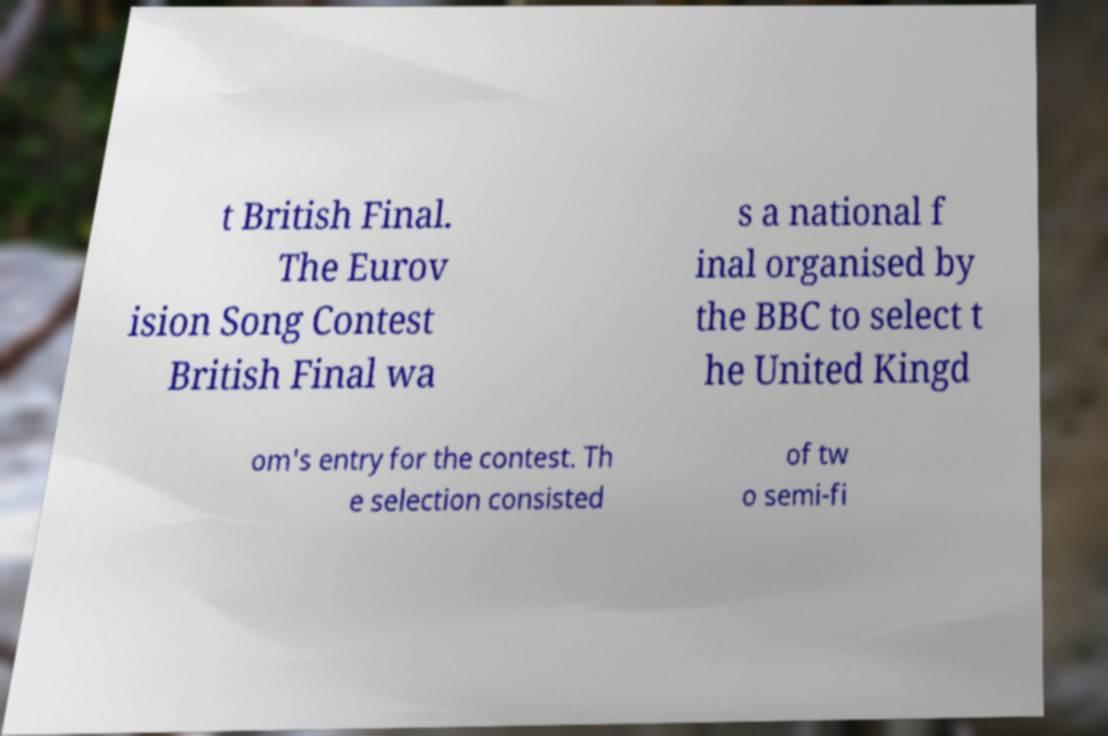Could you extract and type out the text from this image? t British Final. The Eurov ision Song Contest British Final wa s a national f inal organised by the BBC to select t he United Kingd om's entry for the contest. Th e selection consisted of tw o semi-fi 